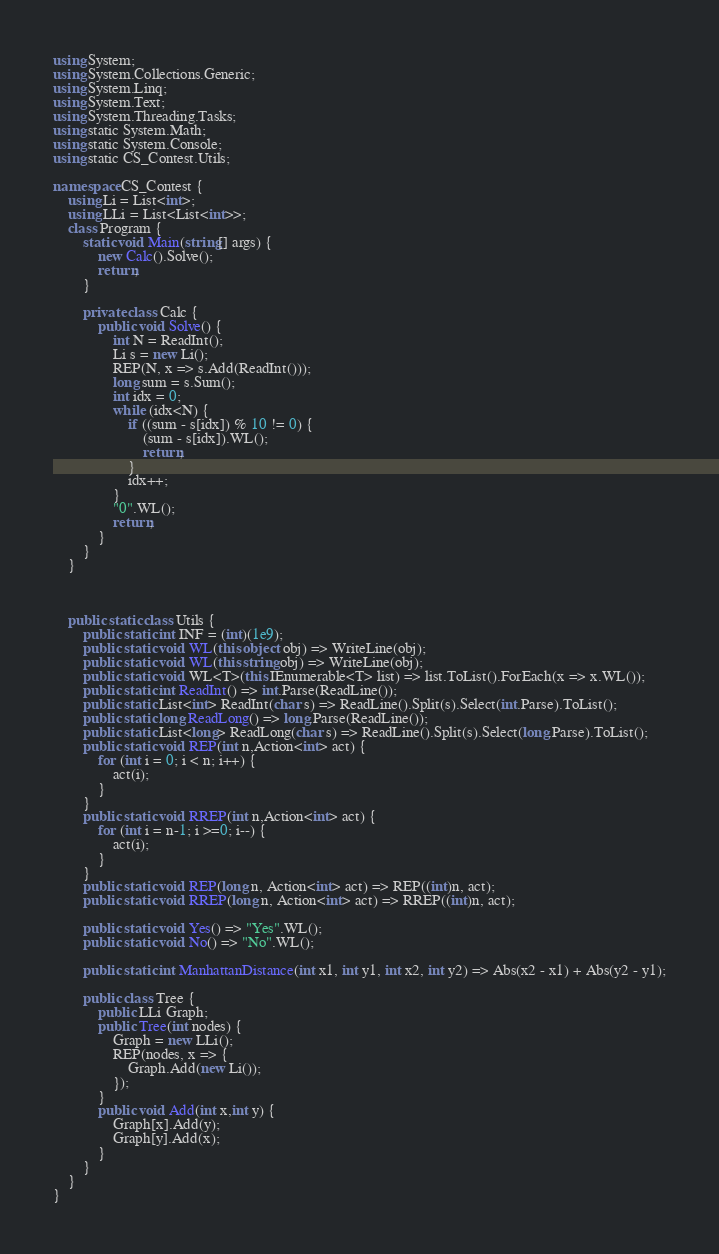<code> <loc_0><loc_0><loc_500><loc_500><_C#_>using System;
using System.Collections.Generic;
using System.Linq;
using System.Text;
using System.Threading.Tasks;
using static System.Math;
using static System.Console;
using static CS_Contest.Utils;

namespace CS_Contest {
	using Li = List<int>;
	using LLi = List<List<int>>;
	class Program {
        static void Main(string[] args) {
			new Calc().Solve();
			return;
        }

		private class Calc {
			public void Solve() {
				int N = ReadInt();
				Li s = new Li();
				REP(N, x => s.Add(ReadInt()));
				long sum = s.Sum();
				int idx = 0;
				while (idx<N) {
					if ((sum - s[idx]) % 10 != 0) {
						(sum - s[idx]).WL();
						return;
					}
					idx++;
				}
				"0".WL();
				return;
			}
		}
    }

	
	
    public static class Utils {
		public static int INF = (int)(1e9);
        public static void WL(this object obj) => WriteLine(obj);
        public static void WL(this string obj) => WriteLine(obj);
        public static void WL<T>(this IEnumerable<T> list) => list.ToList().ForEach(x => x.WL());
		public static int ReadInt() => int.Parse(ReadLine());
		public static List<int> ReadInt(char s) => ReadLine().Split(s).Select(int.Parse).ToList();
		public static long ReadLong() => long.Parse(ReadLine());
		public static List<long> ReadLong(char s) => ReadLine().Split(s).Select(long.Parse).ToList();
		public static void REP(int n,Action<int> act) {
			for (int i = 0; i < n; i++) {
				act(i);
			}
		}
		public static void RREP(int n,Action<int> act) {
			for (int i = n-1; i >=0; i--) {
				act(i);
			}
		}
		public static void REP(long n, Action<int> act) => REP((int)n, act);
		public static void RREP(long n, Action<int> act) => RREP((int)n, act);

		public static void Yes() => "Yes".WL();
		public static void No() => "No".WL();

		public static int ManhattanDistance(int x1, int y1, int x2, int y2) => Abs(x2 - x1) + Abs(y2 - y1);

		public class Tree {
			public LLi Graph;
			public Tree(int nodes) {
				Graph = new LLi();
				REP(nodes, x => {
					Graph.Add(new Li());
				});
			}
			public void Add(int x,int y) {
				Graph[x].Add(y);
				Graph[y].Add(x);
			}
		}
    }
}
</code> 